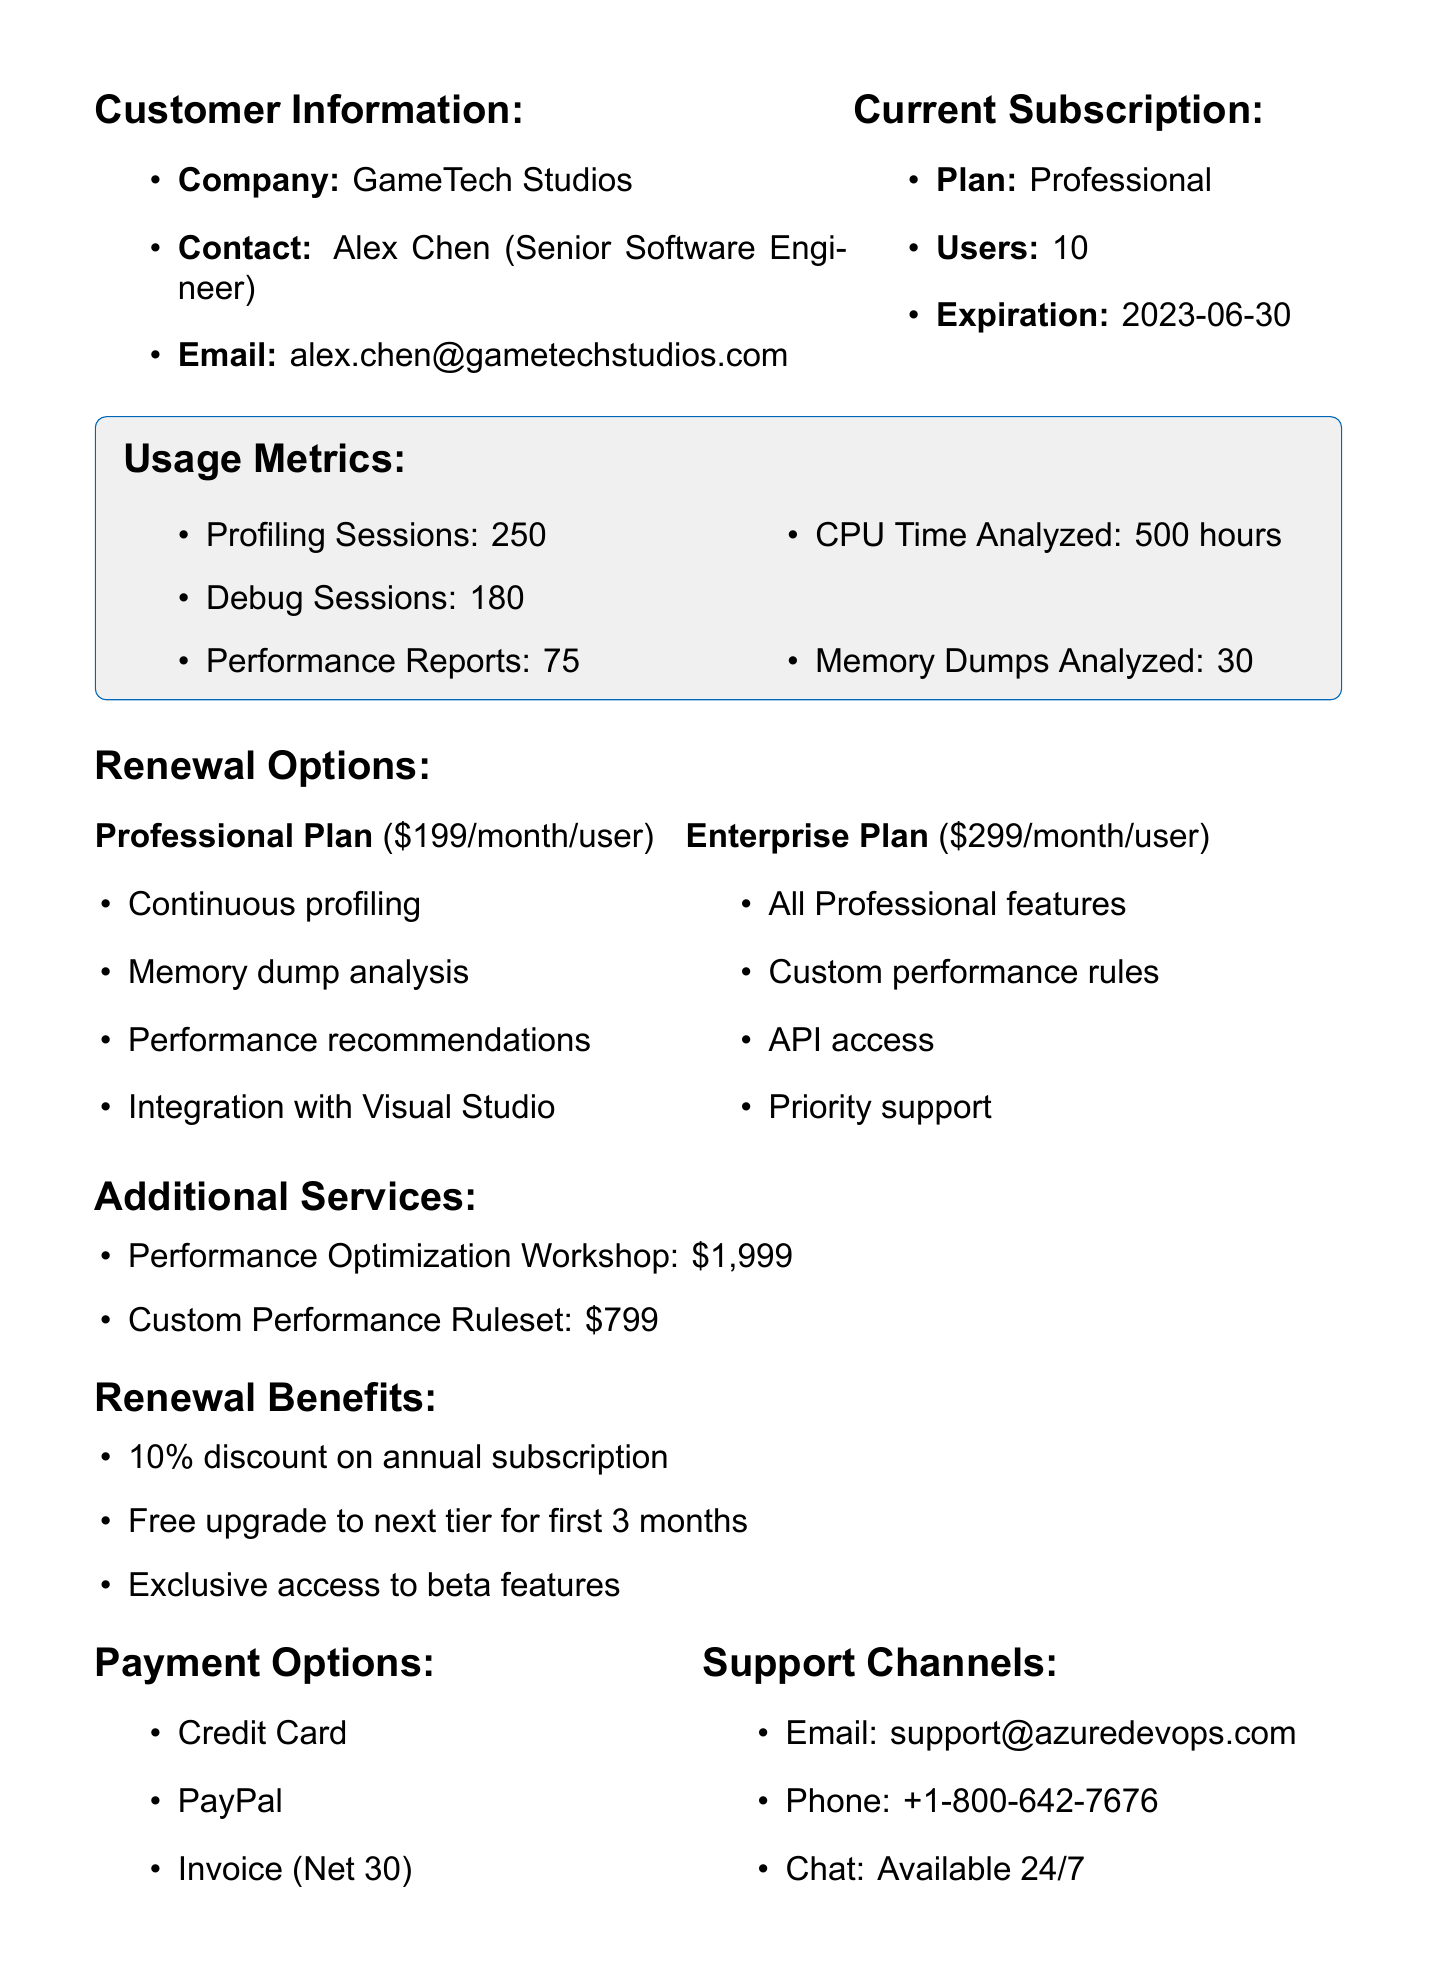What is the customer's name? The customer's name is mentioned in the customer contact section of the document.
Answer: Alex Chen What is the current subscription plan? The current subscription plan is listed under the current subscription section.
Answer: Professional How many profiling sessions were conducted? The number of profiling sessions is found in the usage metrics section of the document.
Answer: 250 What is the price of the Enterprise plan? The price of the Enterprise plan is detailed in the renewal options section.
Answer: $299/month/user What is one of the additional services offered? One of the additional services is mentioned in the additional services section.
Answer: Performance Optimization Workshop What is the minimum commitment for the subscription? The minimum commitment is included in the terms and conditions section of the document.
Answer: 12 months What discount is provided on the annual subscription? The discount for the annual subscription is listed under the renewal benefits section.
Answer: 10% Which payment option is available? The payment options are enumerated in the payment options section of the document.
Answer: Credit Card What support channel is available 24/7? The available support channels provide their availability in the support channels section.
Answer: Chat 